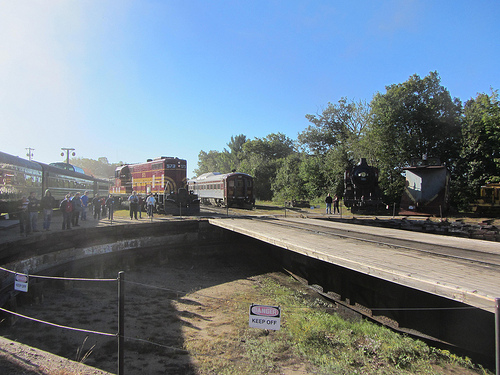Who is on the platform? People are on the platform. 